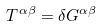<formula> <loc_0><loc_0><loc_500><loc_500>T ^ { \alpha \beta } = \delta G ^ { \alpha \beta }</formula> 